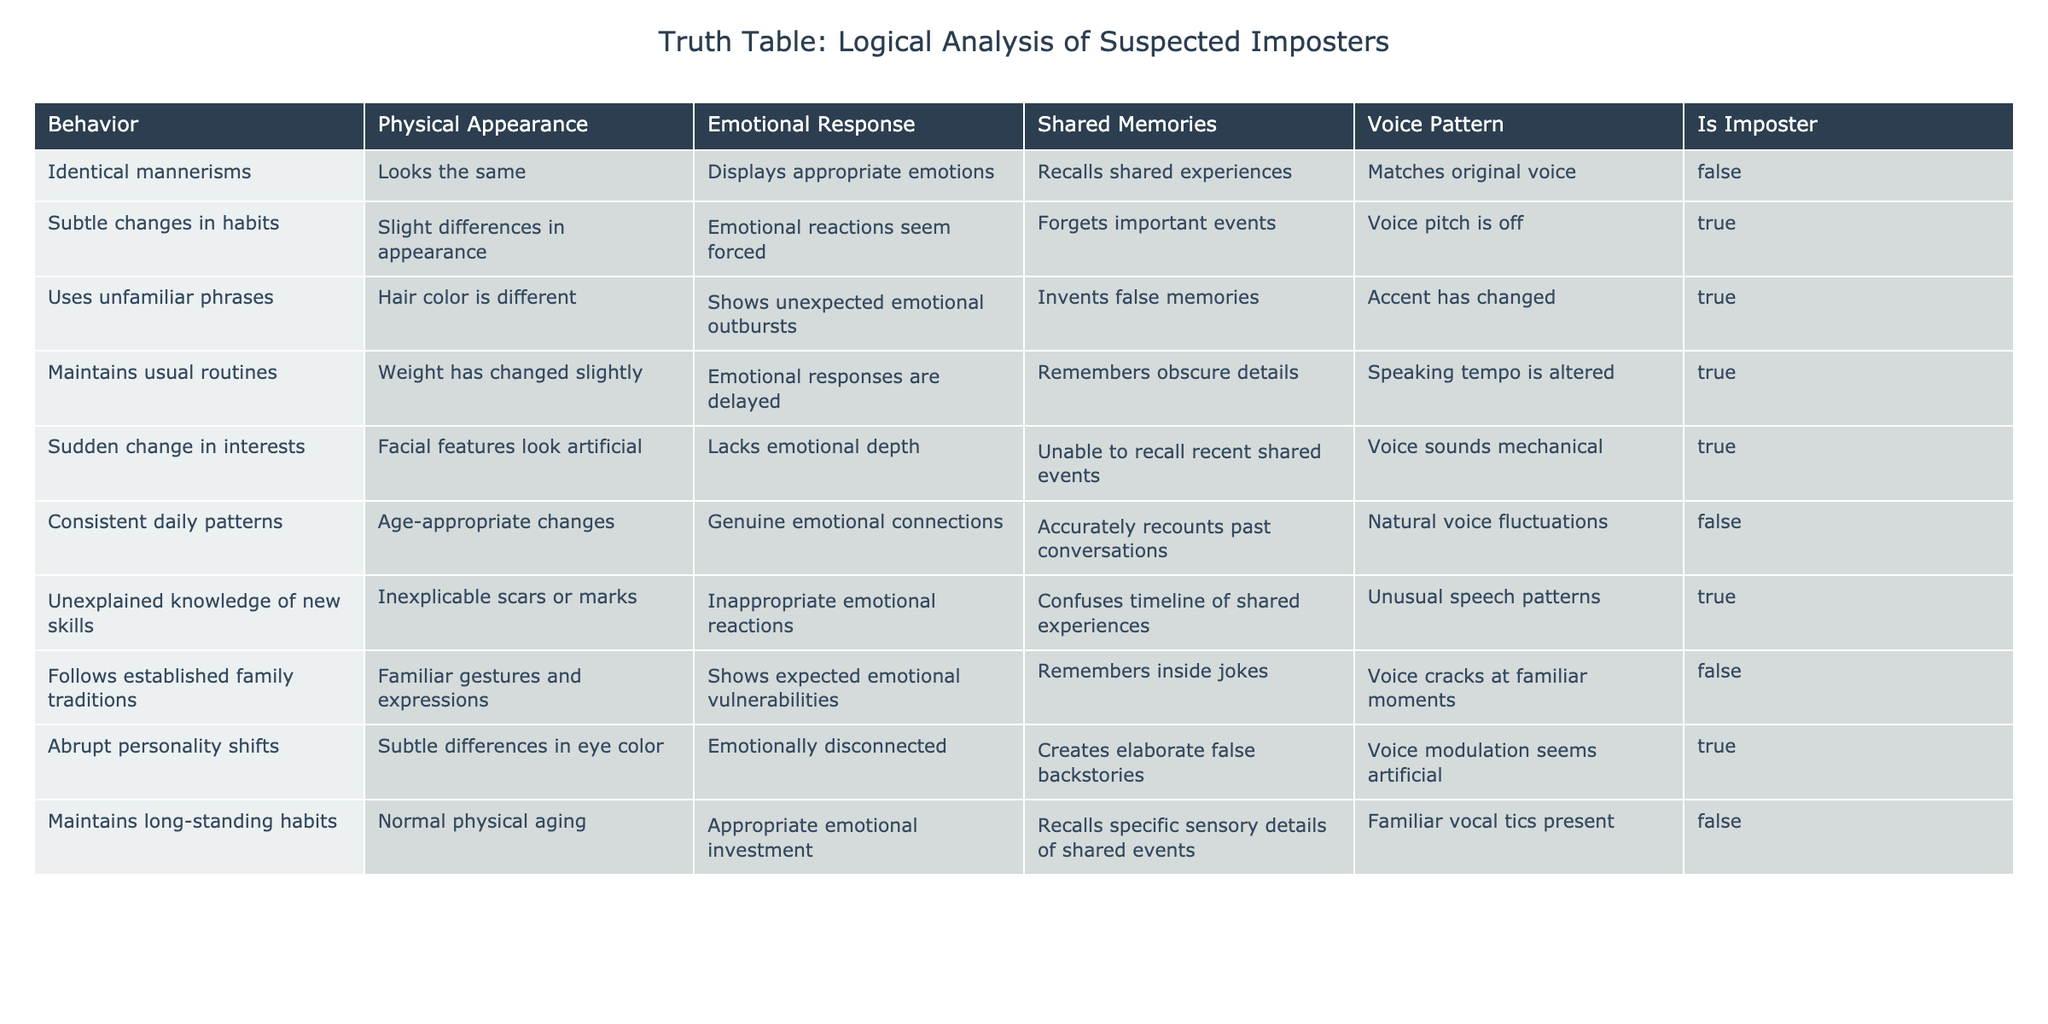What is the physical appearance description for individuals identified as imposters? In the table, there are multiple instances indicating physical appearance traits of imposters. The descriptions include slight differences in appearance, different hair color, artificial facial features, and differences in eye color.
Answer: Varies (slight differences, different hair color, artificial features, eye color changes) How many entries in the table show that the individuals are imposters? Counting the rows where "Is Imposter" is TRUE, we find there are 5 entries that indicate the individuals are imposters.
Answer: 5 What percentage of the behaviors listed in the table are associated with imposters? There are 10 total entries in the table, and 5 of them identify the individuals as imposters. Thus, the percentage is (5/10) * 100 = 50%.
Answer: 50% Which emotional response is displayed by the entry with "Uses unfamiliar phrases"? In the row describing the use of unfamiliar phrases, the emotional response listed is "Shows unexpected emotional outbursts".
Answer: Shows unexpected emotional outbursts Is it true that maintaining long-standing habits correlates with not being an imposter? Yes, in the table, the entry for maintaining long-standing habits indicates "Is Imposter" is FALSE, suggesting that this behavior is associated with being genuine.
Answer: Yes What are the behaviors that have both emotional responses that seem forced and forgetfulness of important events? Only one entry matches this description. It describes subtle changes in habits alongside emotional reactions being forced and forgetting important events.
Answer: Subtle changes in habits What is the relationship between voice patterns and the identification of imposters? Among the entries marked as imposters, we observe varied voice patterns, including "Voice pitch is off", "Accent has changed", "Voice sounds mechanical", and "Voice modulation seems artificial", which correlates with being labeled an imposter.
Answer: Varied (among imposters) How many rows describe emotional responses that lack depth and also include false memories? Upon reviewing the table, there is one entry where the emotional response lacks depth while simultaneously involving the creation of false memories.
Answer: 1 If we analyze behaviors, how many of the imposters have abrupt personality shifts? Looking at the entries, we find that the row describing imposters notes that there is one instance of abrupt personality shifts recorded among those identified as imposters.
Answer: 1 